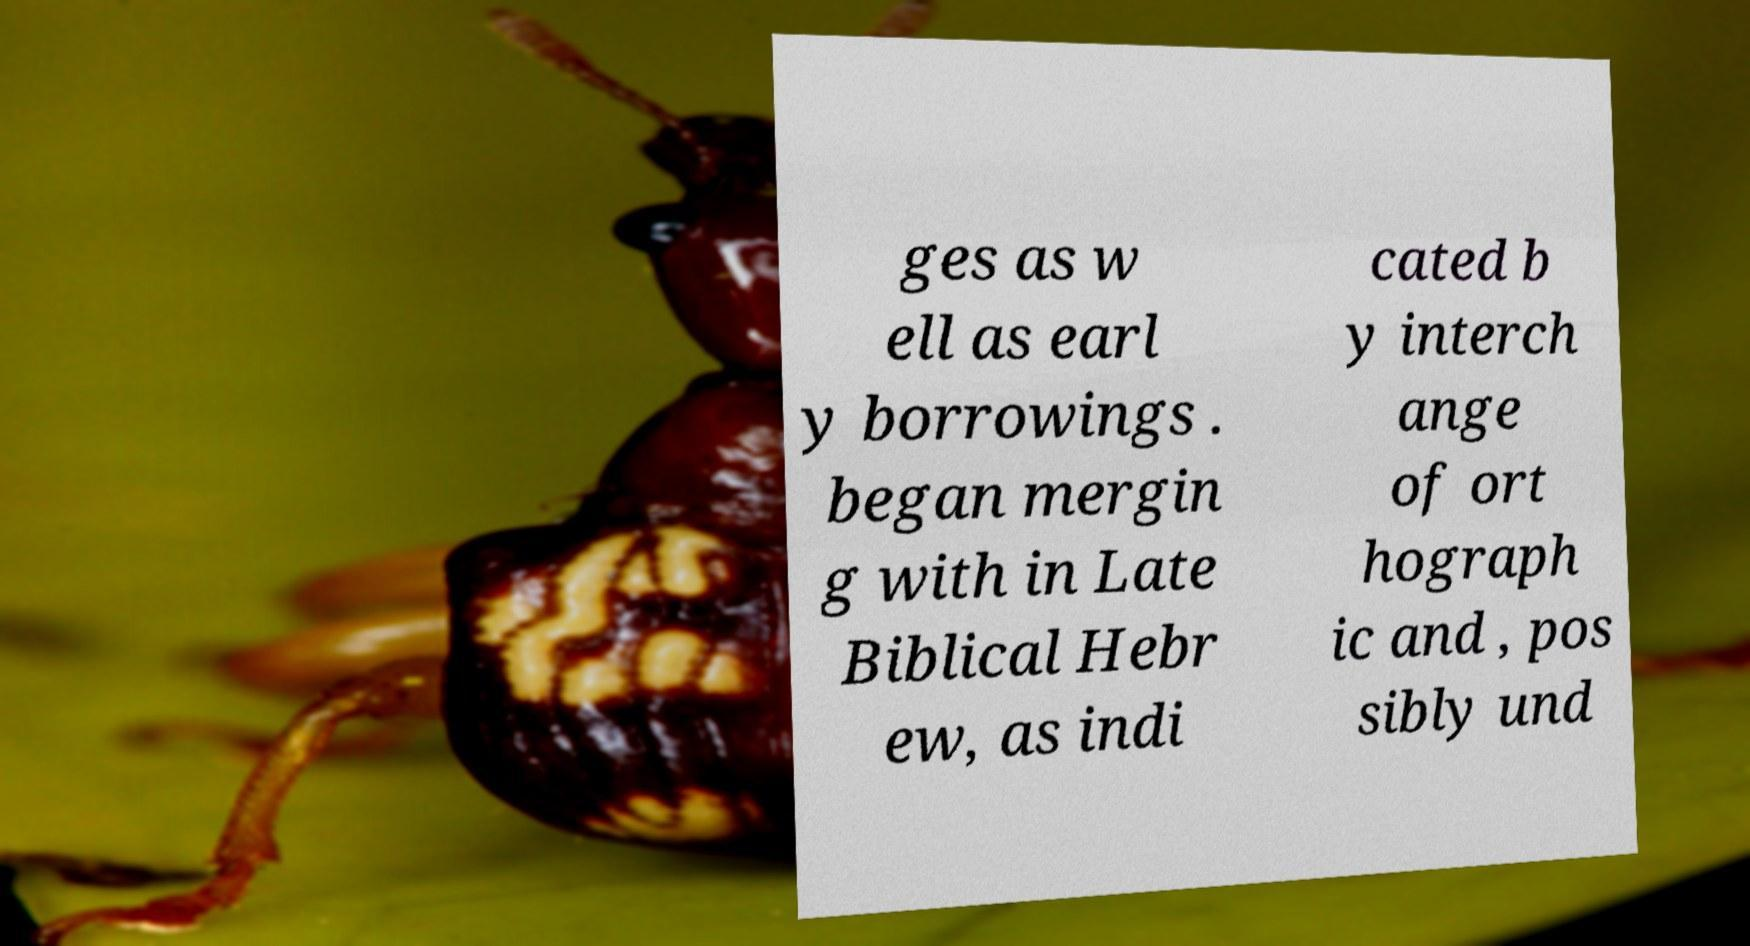I need the written content from this picture converted into text. Can you do that? ges as w ell as earl y borrowings . began mergin g with in Late Biblical Hebr ew, as indi cated b y interch ange of ort hograph ic and , pos sibly und 